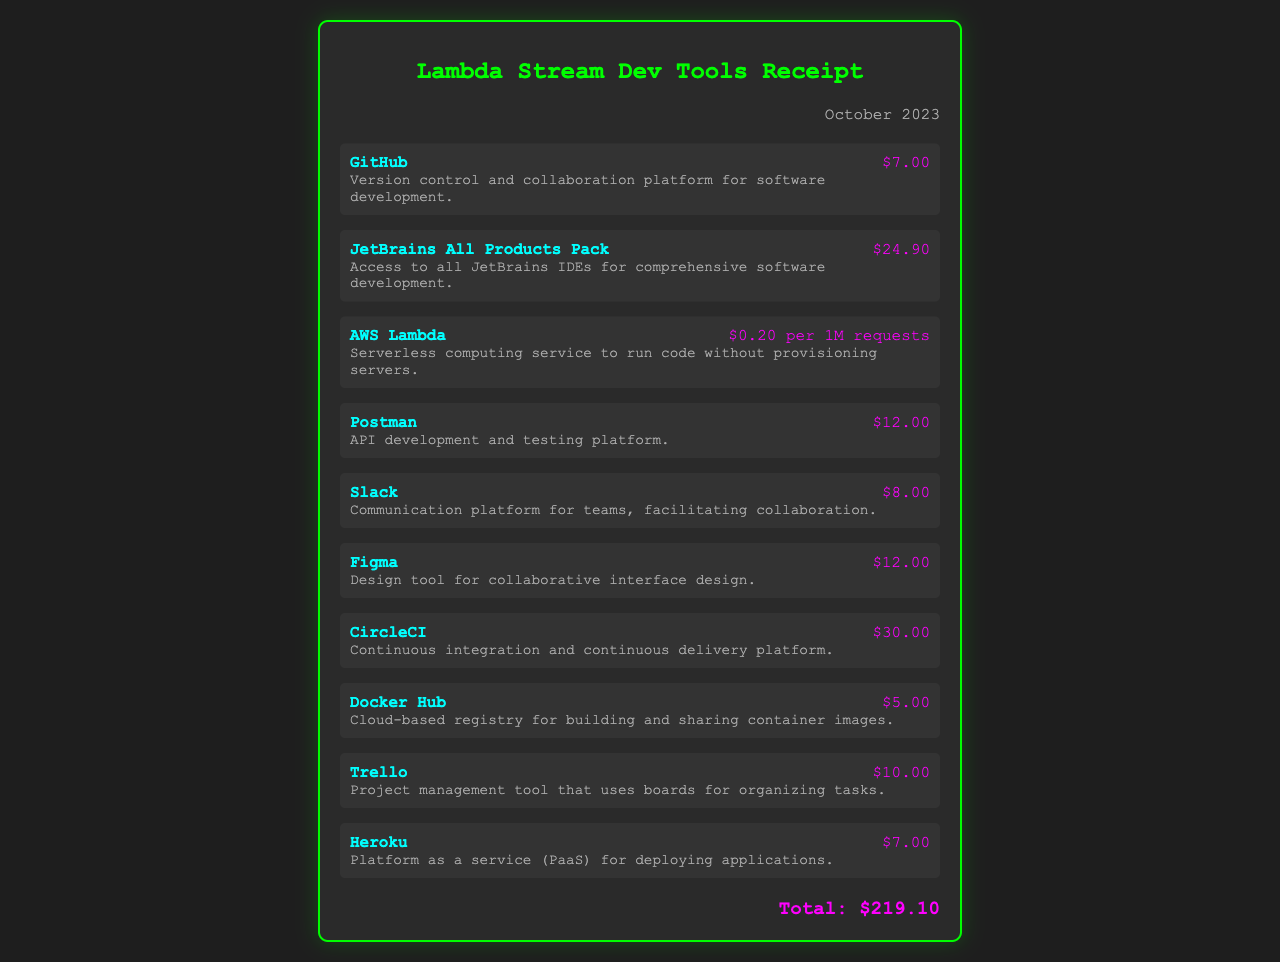what is the total cost of subscriptions? The total cost of subscriptions is clearly stated in the document as the sum of all individual service costs, which amounts to $219.10.
Answer: $219.10 how much does GitHub cost? The document lists GitHub's subscription fee directly, indicating that it costs $7.00.
Answer: $7.00 what is the monthly fee for Slack? The document specifies that the monthly fee for Slack is $8.00.
Answer: $8.00 how many services are listed in the receipt? By counting the individual items detailed in the receipt, we can determine the total as 10 different services.
Answer: 10 which service has the highest subscription fee? The receipt shows that CircleCI has the highest subscription fee listed at $30.00.
Answer: $30.00 what is the cost of AWS Lambda per million requests? The document provides the pricing for AWS Lambda as $0.20 per 1M requests.
Answer: $0.20 per 1M requests when was this receipt issued? The date on the receipt indicates it was issued in October 2023.
Answer: October 2023 what type of platform is Heroku categorized as? The receipt describes Heroku as a Platform as a Service (PaaS).
Answer: Platform as a Service (PaaS) which service is associated with API development? The description in the document indicates that Postman is the service associated with API development.
Answer: Postman 